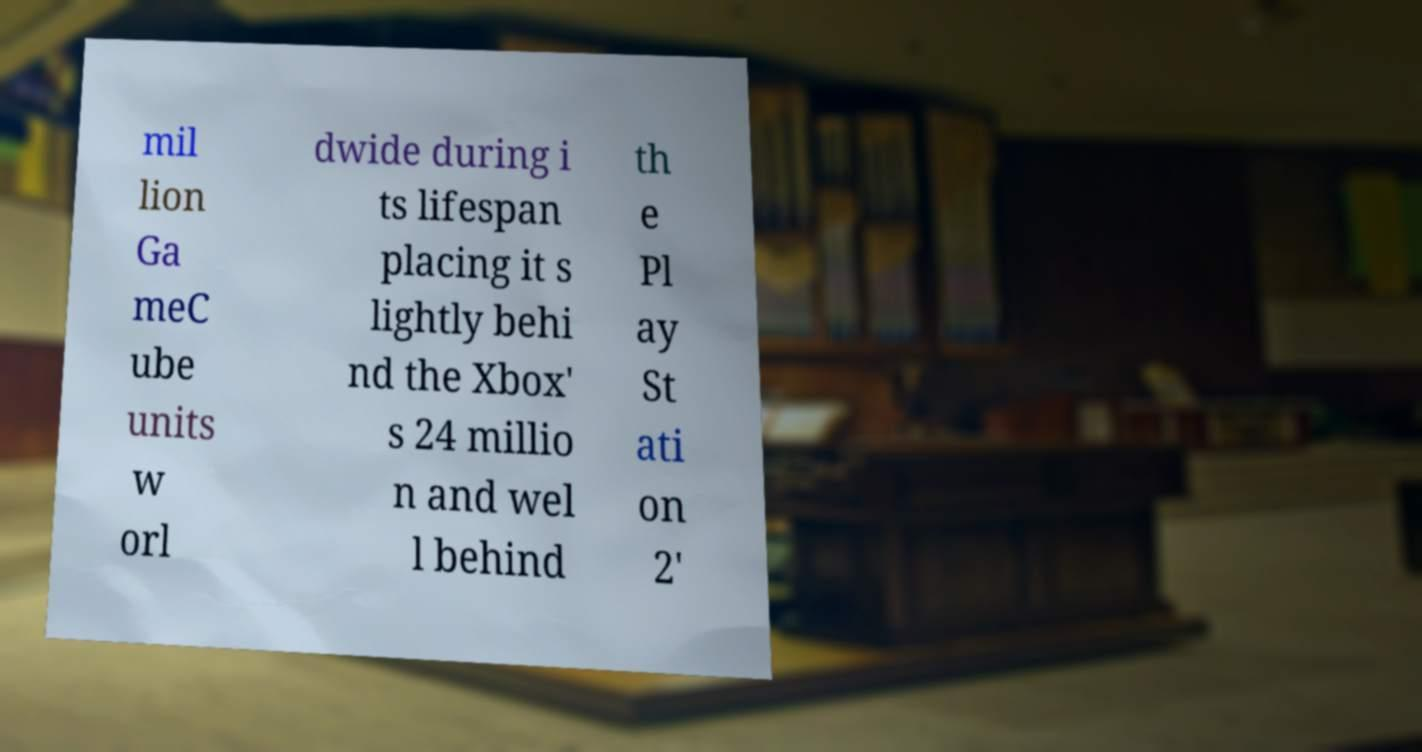What messages or text are displayed in this image? I need them in a readable, typed format. mil lion Ga meC ube units w orl dwide during i ts lifespan placing it s lightly behi nd the Xbox' s 24 millio n and wel l behind th e Pl ay St ati on 2' 